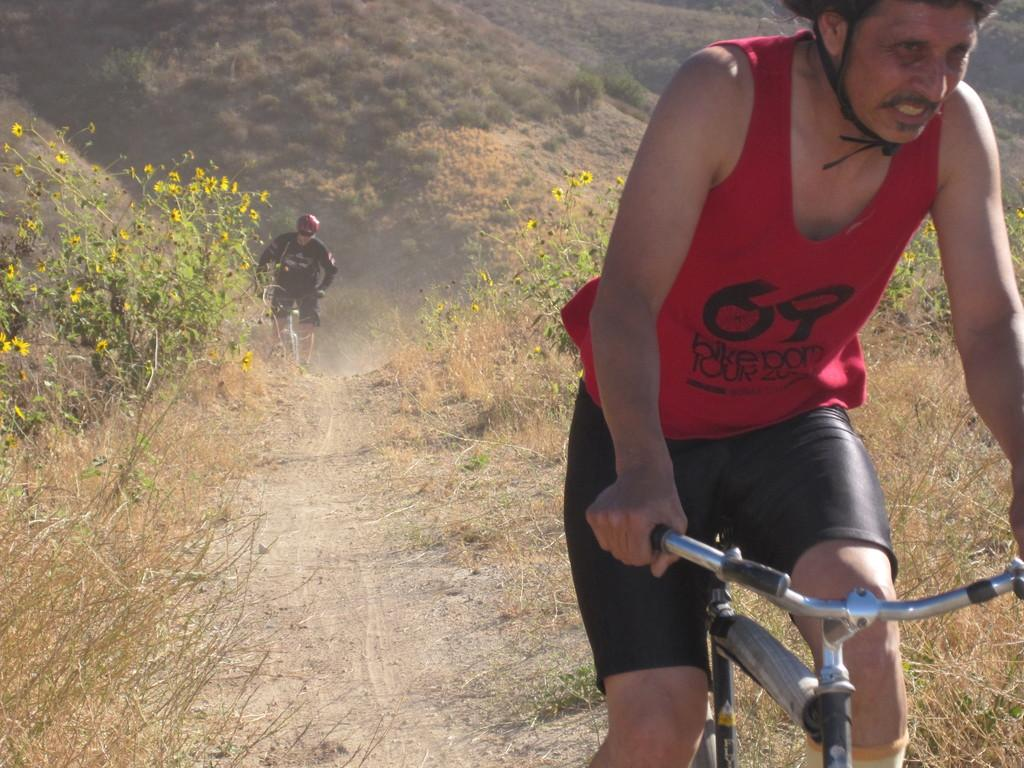How many people are in the image? There are two persons in the image. What are the two persons doing in the image? The two persons are riding a bicycle. Where is the bicycle located in the image? The bicycle is on a road. What can be seen in the background of the image? There is grass, flowering plants, and mountains in the background of the image. When was the image likely taken? The image was likely taken during the day, as there is sufficient light to see the details. What type of disease is affecting the bicycle in the image? There is no disease affecting the bicycle in the image; it appears to be in good condition. What scientific theory can be observed in the image? There is no scientific theory observable in the image; it is a photograph of two people riding a bicycle on a road. 